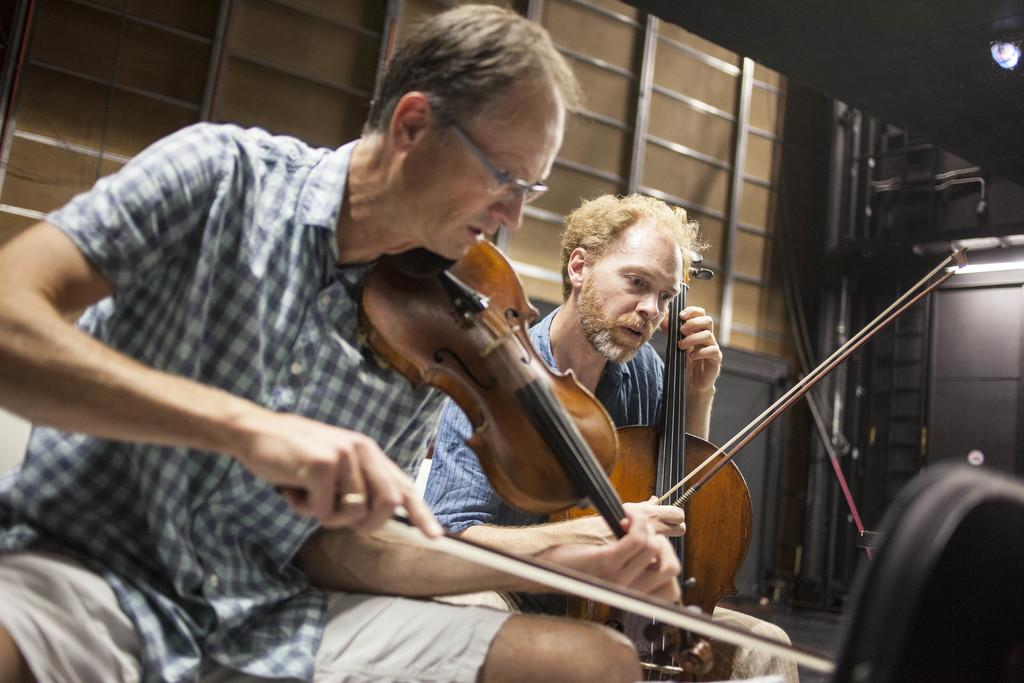How many people are in the image? There are two persons in the image. What are the persons doing in the image? The persons are sitting and holding music instruments. What color are the music instruments? The music instruments are yellow in color. What can be seen in the background of the image? There is a yellow color wall made of woods in the background. What type of nation is depicted on the wall in the image? There is no nation depicted on the wall in the image; it is a yellow color wall made of woods. Can you tell me how many errors are present in the image? There are no errors present in the image; it is a clear and accurate representation of the scene. 